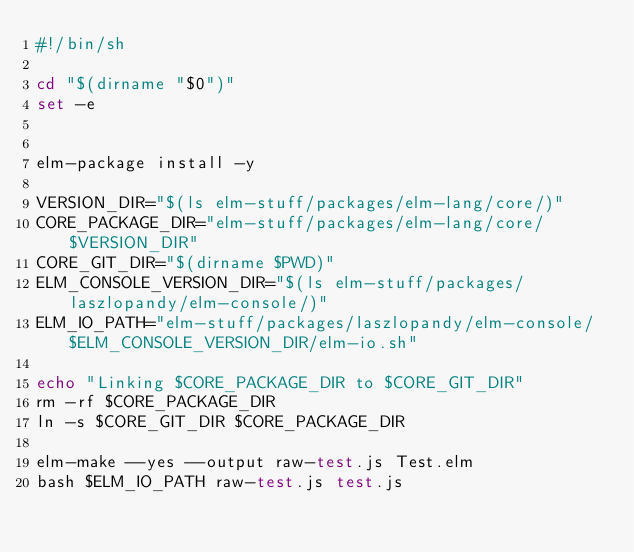Convert code to text. <code><loc_0><loc_0><loc_500><loc_500><_Bash_>#!/bin/sh

cd "$(dirname "$0")"
set -e


elm-package install -y

VERSION_DIR="$(ls elm-stuff/packages/elm-lang/core/)"
CORE_PACKAGE_DIR="elm-stuff/packages/elm-lang/core/$VERSION_DIR"
CORE_GIT_DIR="$(dirname $PWD)"
ELM_CONSOLE_VERSION_DIR="$(ls elm-stuff/packages/laszlopandy/elm-console/)"
ELM_IO_PATH="elm-stuff/packages/laszlopandy/elm-console/$ELM_CONSOLE_VERSION_DIR/elm-io.sh"

echo "Linking $CORE_PACKAGE_DIR to $CORE_GIT_DIR"
rm -rf $CORE_PACKAGE_DIR
ln -s $CORE_GIT_DIR $CORE_PACKAGE_DIR

elm-make --yes --output raw-test.js Test.elm
bash $ELM_IO_PATH raw-test.js test.js </code> 